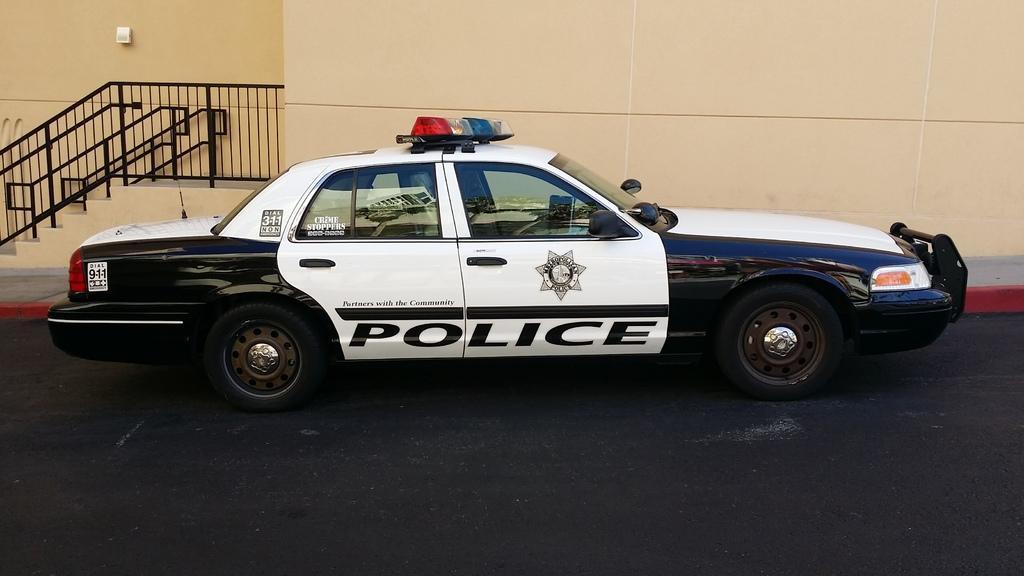How would you summarize this image in a sentence or two? In front of the image there is a car on the road. Behind the car there is a wall. On the left side of the image there are stairs. There are railings. 